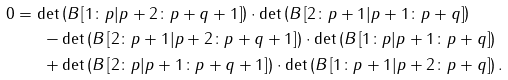<formula> <loc_0><loc_0><loc_500><loc_500>0 & = \det \left ( B \left [ 1 \colon p | p + 2 \colon p + q + 1 \right ] \right ) \cdot \det \left ( B \left [ 2 \colon p + 1 | p + 1 \colon p + q \right ] \right ) \\ & \quad \ \ - \det \left ( B \left [ 2 \colon p + 1 | p + 2 \colon p + q + 1 \right ] \right ) \cdot \det \left ( B \left [ 1 \colon p | p + 1 \colon p + q \right ] \right ) \\ & \quad \ \ + \det \left ( B \left [ 2 \colon p | p + 1 \colon p + q + 1 \right ] \right ) \cdot \det \left ( B \left [ 1 \colon p + 1 | p + 2 \colon p + q \right ] \right ) .</formula> 